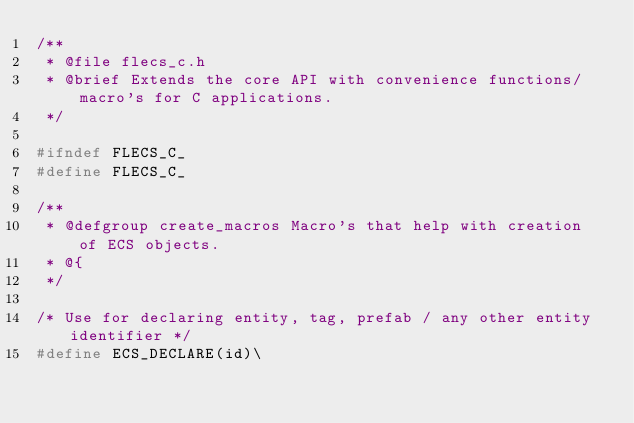<code> <loc_0><loc_0><loc_500><loc_500><_C_>/**
 * @file flecs_c.h
 * @brief Extends the core API with convenience functions/macro's for C applications.
 */

#ifndef FLECS_C_
#define FLECS_C_

/**
 * @defgroup create_macros Macro's that help with creation of ECS objects.
 * @{
 */

/* Use for declaring entity, tag, prefab / any other entity identifier */
#define ECS_DECLARE(id)\</code> 